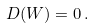<formula> <loc_0><loc_0><loc_500><loc_500>D ( W ) = 0 \, .</formula> 